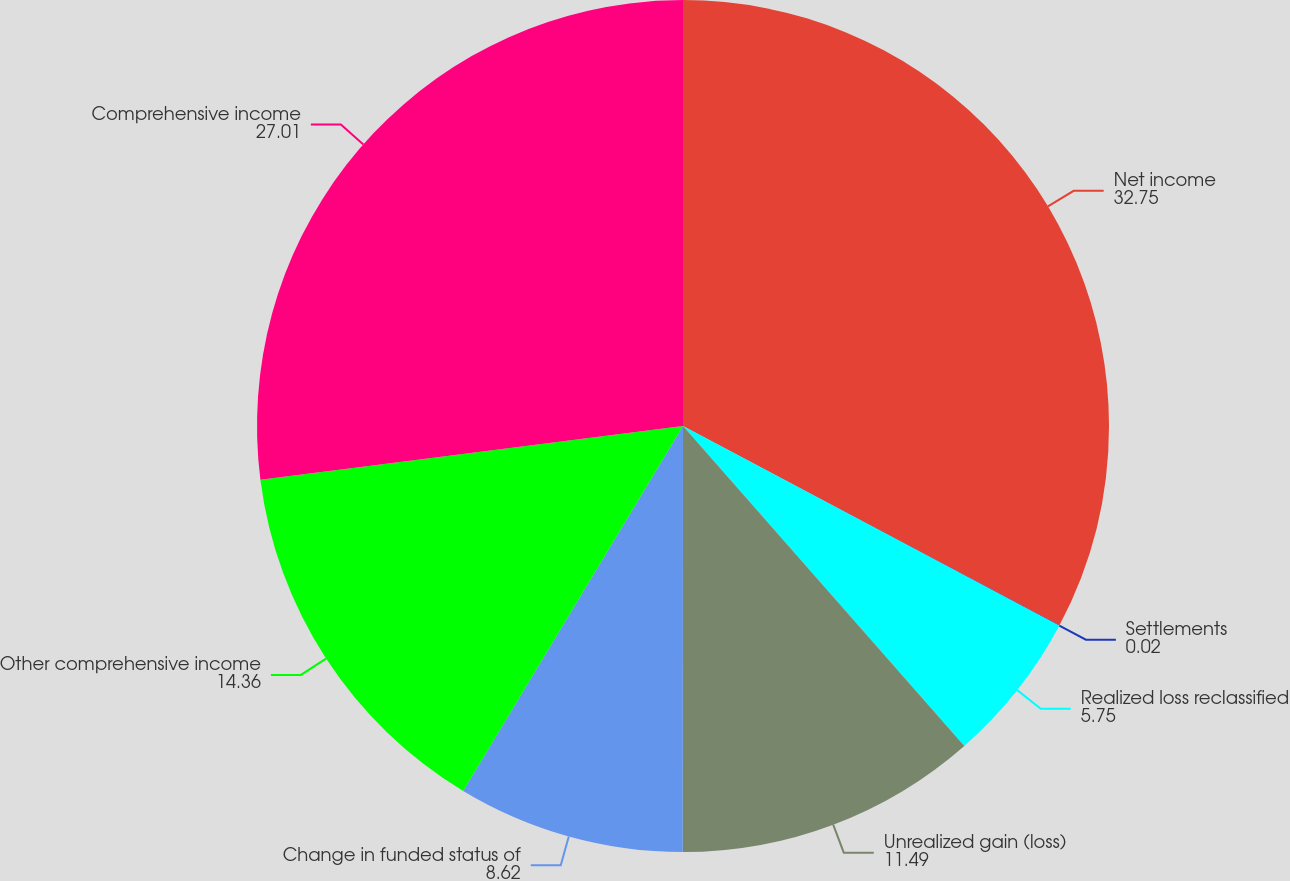Convert chart to OTSL. <chart><loc_0><loc_0><loc_500><loc_500><pie_chart><fcel>Net income<fcel>Settlements<fcel>Realized loss reclassified<fcel>Unrealized gain (loss)<fcel>Change in funded status of<fcel>Other comprehensive income<fcel>Comprehensive income<nl><fcel>32.75%<fcel>0.02%<fcel>5.75%<fcel>11.49%<fcel>8.62%<fcel>14.36%<fcel>27.01%<nl></chart> 